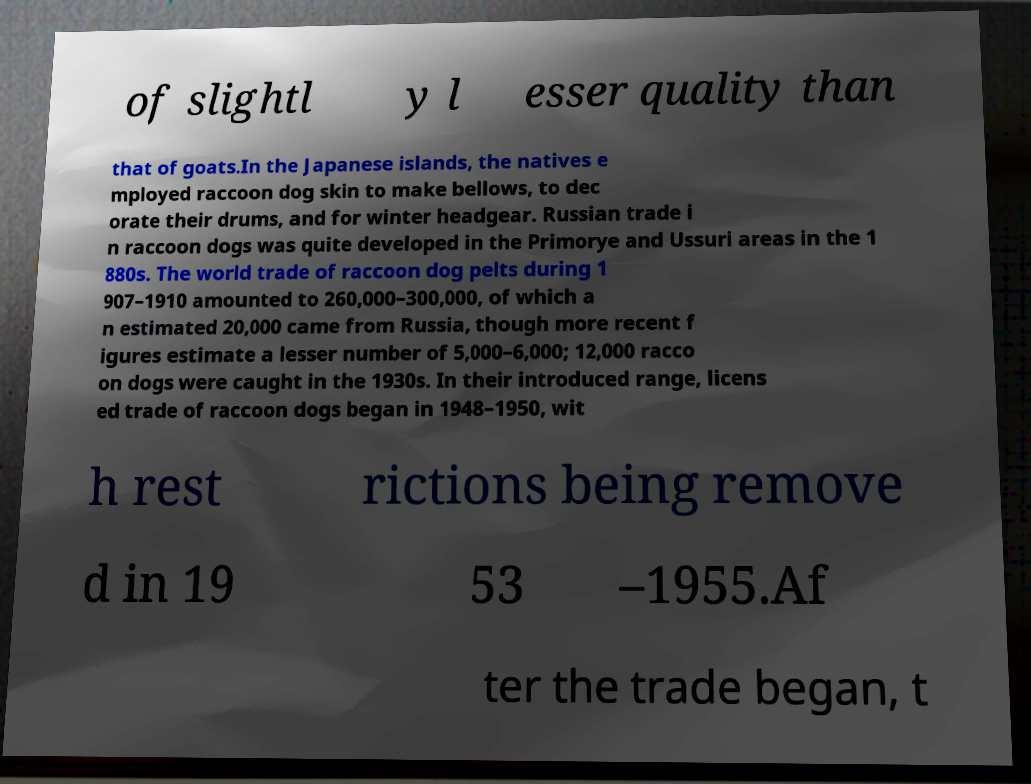Please identify and transcribe the text found in this image. of slightl y l esser quality than that of goats.In the Japanese islands, the natives e mployed raccoon dog skin to make bellows, to dec orate their drums, and for winter headgear. Russian trade i n raccoon dogs was quite developed in the Primorye and Ussuri areas in the 1 880s. The world trade of raccoon dog pelts during 1 907–1910 amounted to 260,000–300,000, of which a n estimated 20,000 came from Russia, though more recent f igures estimate a lesser number of 5,000–6,000; 12,000 racco on dogs were caught in the 1930s. In their introduced range, licens ed trade of raccoon dogs began in 1948–1950, wit h rest rictions being remove d in 19 53 –1955.Af ter the trade began, t 